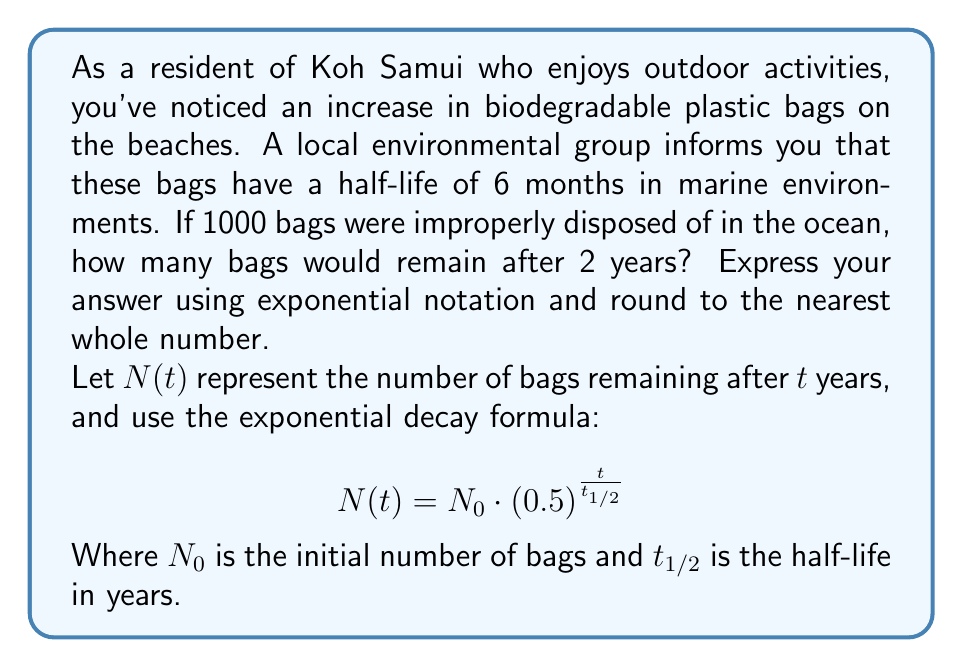Show me your answer to this math problem. To solve this problem, we'll use the exponential decay formula:

$$N(t) = N_0 \cdot (0.5)^{\frac{t}{t_{1/2}}}$$

Given:
- Initial number of bags, $N_0 = 1000$
- Half-life, $t_{1/2} = 6$ months $= 0.5$ years
- Time elapsed, $t = 2$ years

Step 1: Substitute the values into the formula:
$$N(2) = 1000 \cdot (0.5)^{\frac{2}{0.5}}$$

Step 2: Simplify the exponent:
$$N(2) = 1000 \cdot (0.5)^4$$

Step 3: Calculate the result:
$$N(2) = 1000 \cdot 0.0625 = 62.5$$

Step 4: Round to the nearest whole number:
$$N(2) \approx 63$$

Therefore, after 2 years, approximately 63 bags would remain.
Answer: 63 bags 